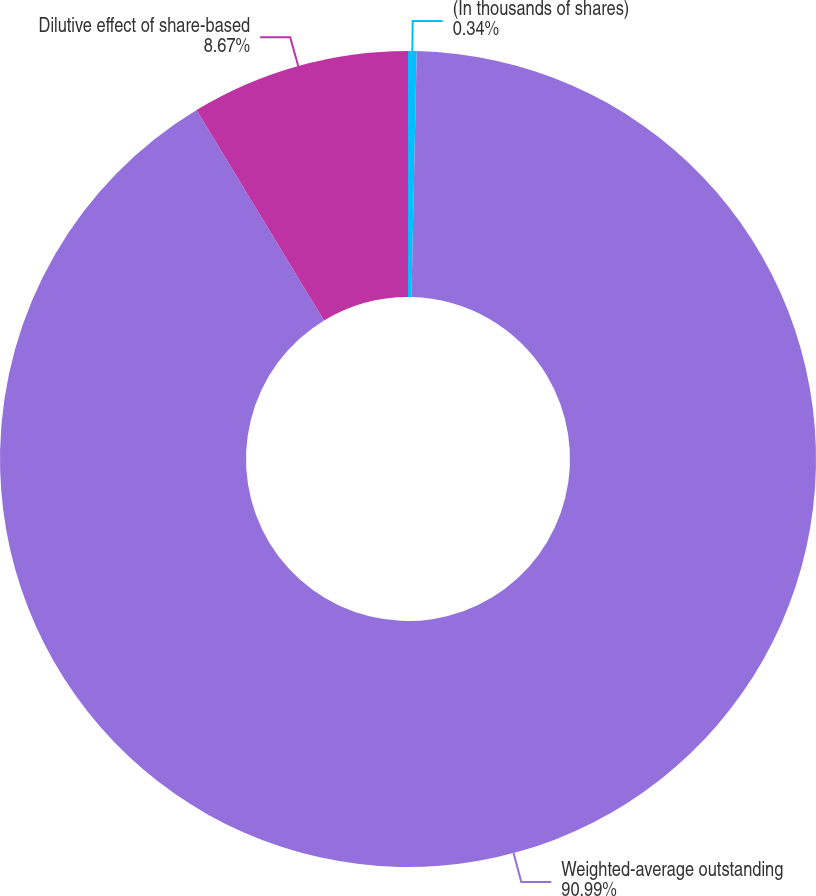Convert chart. <chart><loc_0><loc_0><loc_500><loc_500><pie_chart><fcel>(In thousands of shares)<fcel>Weighted-average outstanding<fcel>Dilutive effect of share-based<nl><fcel>0.34%<fcel>90.99%<fcel>8.67%<nl></chart> 